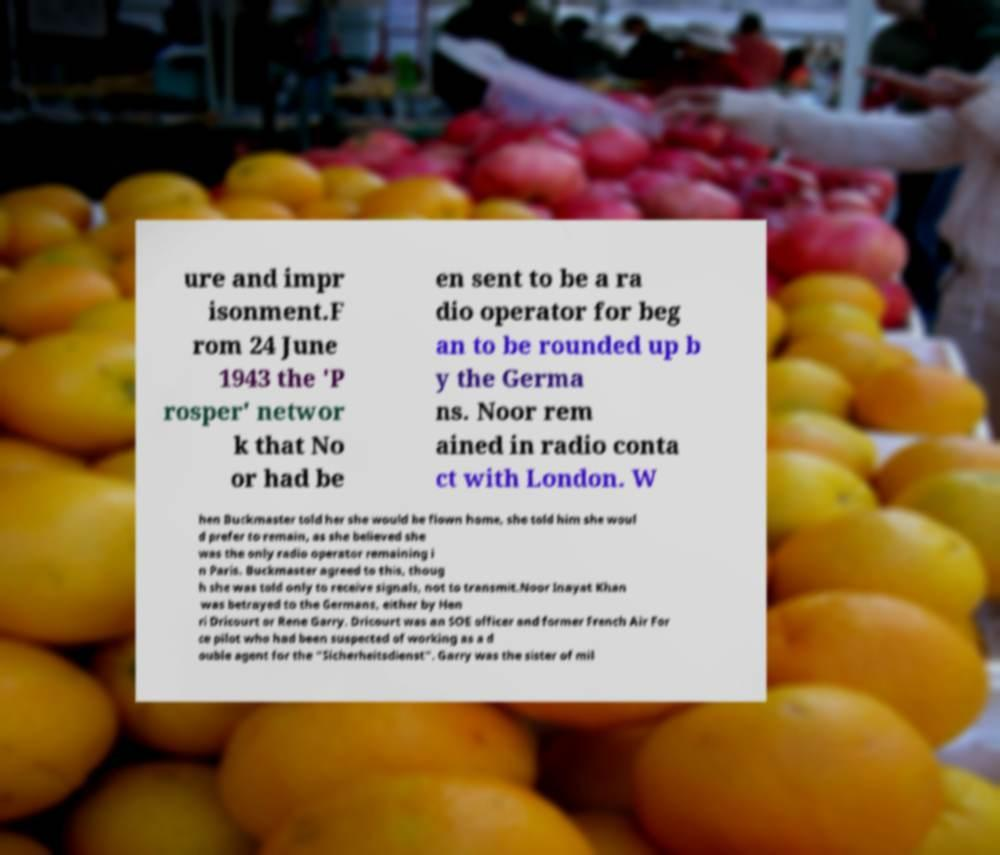I need the written content from this picture converted into text. Can you do that? ure and impr isonment.F rom 24 June 1943 the 'P rosper' networ k that No or had be en sent to be a ra dio operator for beg an to be rounded up b y the Germa ns. Noor rem ained in radio conta ct with London. W hen Buckmaster told her she would be flown home, she told him she woul d prefer to remain, as she believed she was the only radio operator remaining i n Paris. Buckmaster agreed to this, thoug h she was told only to receive signals, not to transmit.Noor Inayat Khan was betrayed to the Germans, either by Hen ri Dricourt or Rene Garry. Dricourt was an SOE officer and former French Air For ce pilot who had been suspected of working as a d ouble agent for the "Sicherheitsdienst". Garry was the sister of mil 